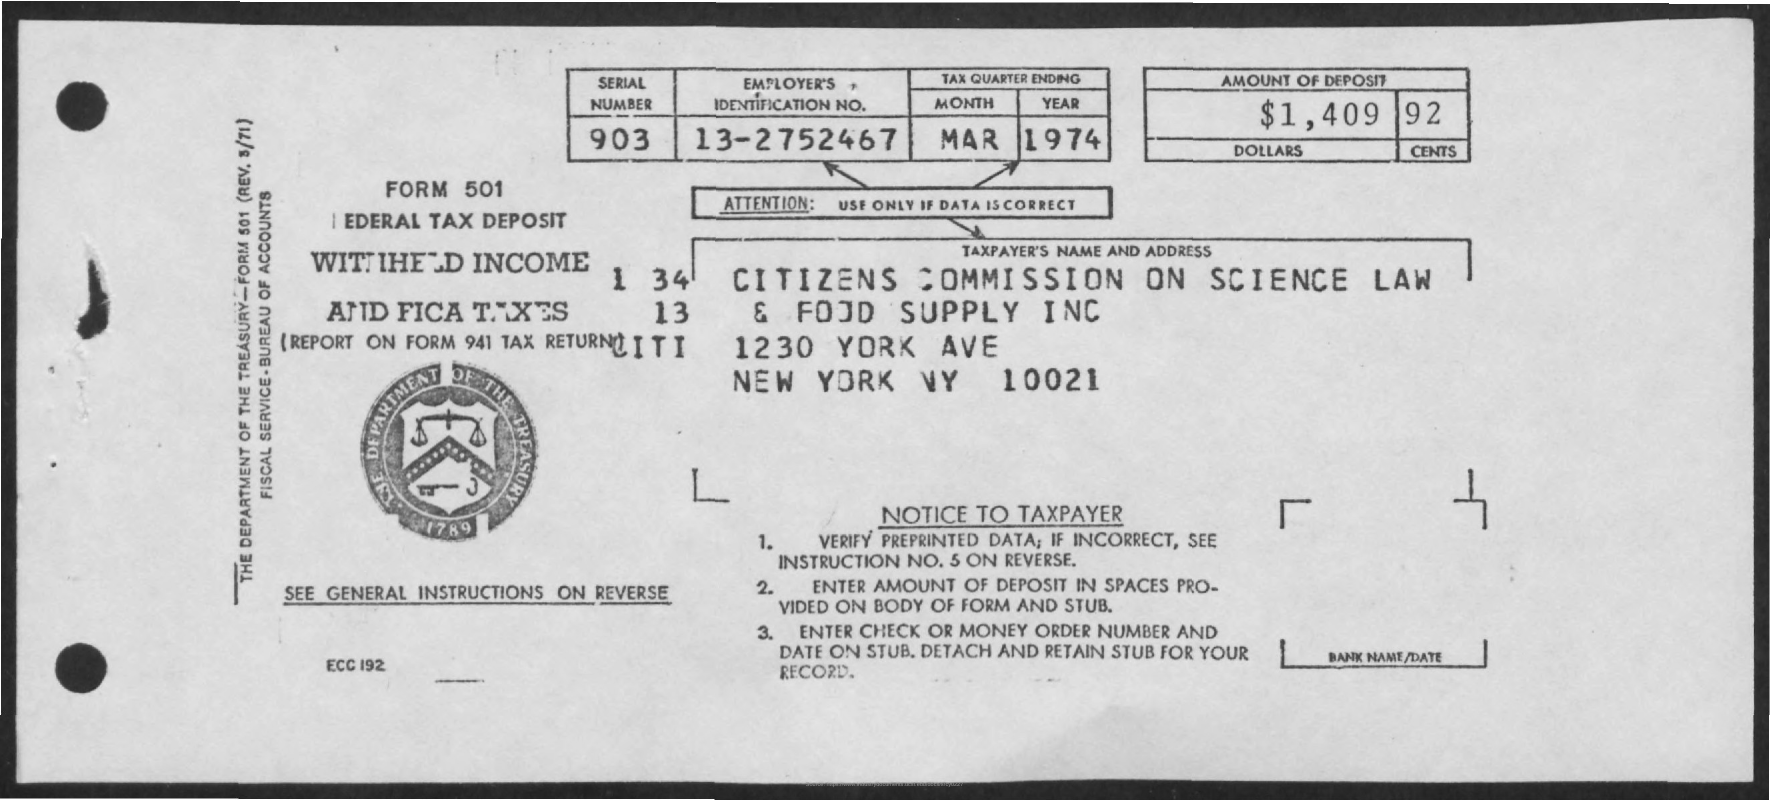What is the Serial Number ?
Give a very brief answer. 903. How much amount Deposit ?
Offer a very short reply. $1,409-92. What is written in the Attention Field ?
Make the answer very short. USE ONLY IF DATA IS CORRECT. 